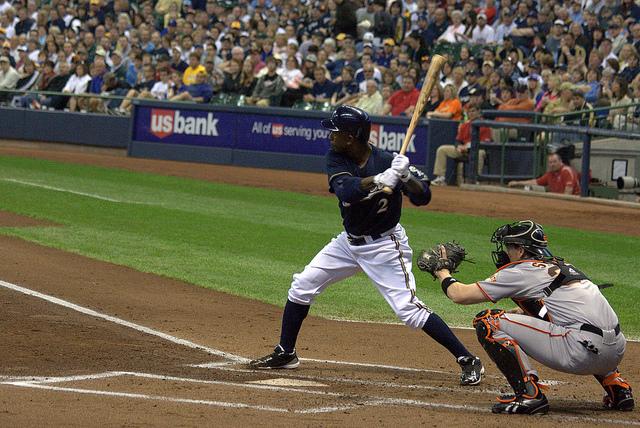What is the color of the batter's uniform?
Give a very brief answer. Blue and white. What sport is this?
Short answer required. Baseball. What does the blue sign in the background say?
Write a very short answer. Us bank. What bank is advertised behind the batter?
Short answer required. Us bank. What is the batter's jersey number?
Write a very short answer. 2. How many people are wearing protective face masks?
Answer briefly. 1. 